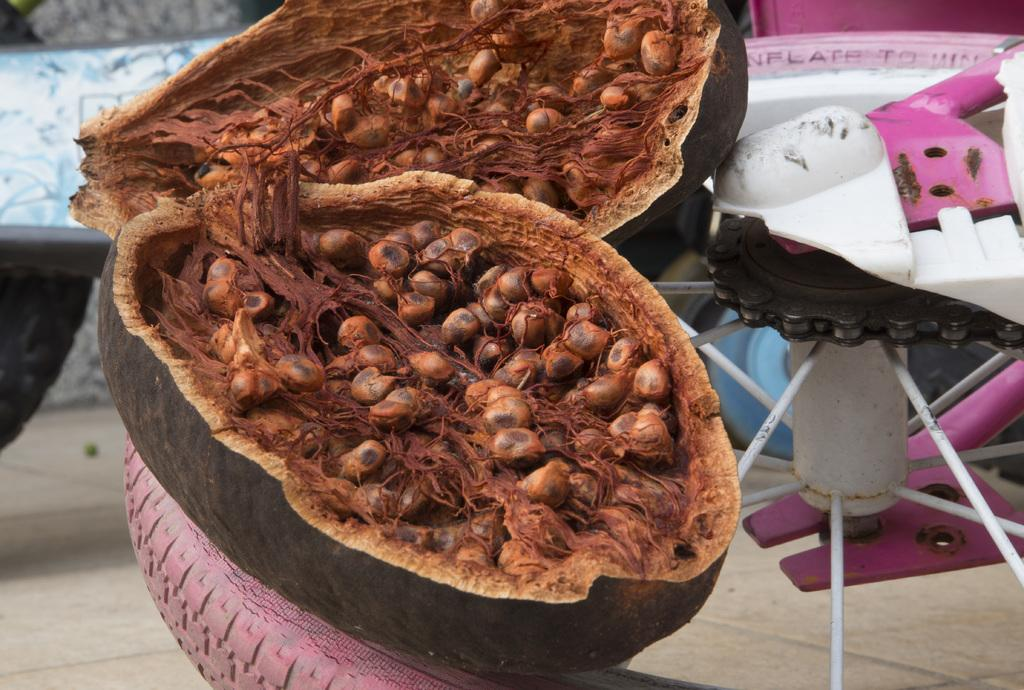What type of food is present in the image? There is fruit in the image. Where is the fruit located? The fruit is placed on a bicycle wheel. What type of impulse can be seen affecting the fruit in the image? There is no impulse affecting the fruit in the image; it is simply placed on a bicycle wheel. Are there any trains visible in the image? No, there are no trains present in the image. Can you see a duck in the image? No, there is no duck present in the image. 